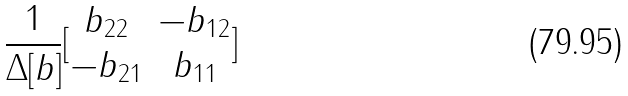<formula> <loc_0><loc_0><loc_500><loc_500>\frac { 1 } { \Delta [ b ] } [ \begin{matrix} b _ { 2 2 } & - b _ { 1 2 } \\ - b _ { 2 1 } & b _ { 1 1 } \end{matrix} ]</formula> 